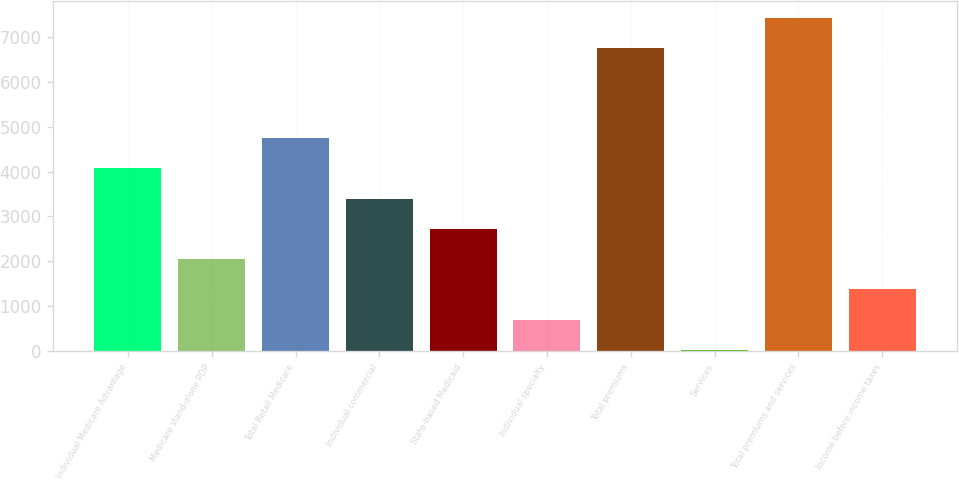Convert chart. <chart><loc_0><loc_0><loc_500><loc_500><bar_chart><fcel>Individual Medicare Advantage<fcel>Medicare stand-alone PDP<fcel>Total Retail Medicare<fcel>Individual commercial<fcel>State-based Medicaid<fcel>Individual specialty<fcel>Total premiums<fcel>Services<fcel>Total premiums and services<fcel>Income before income taxes<nl><fcel>4073<fcel>2048<fcel>4748<fcel>3398<fcel>2723<fcel>698<fcel>6750<fcel>23<fcel>7425<fcel>1373<nl></chart> 